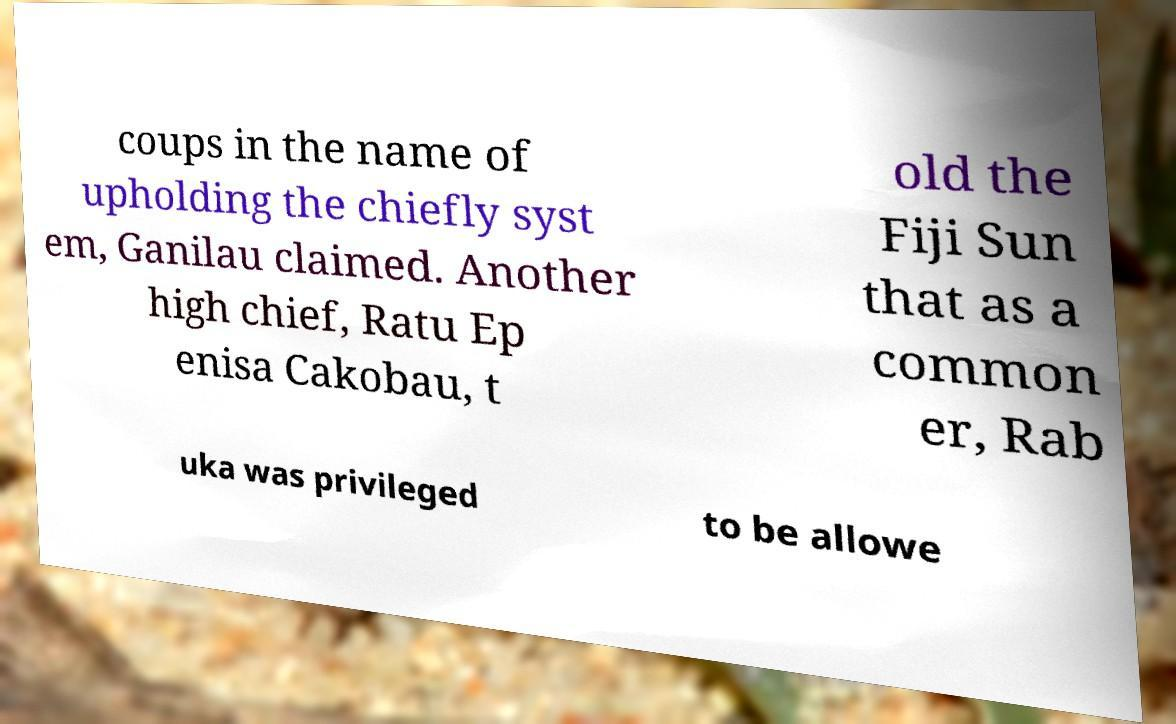Can you accurately transcribe the text from the provided image for me? coups in the name of upholding the chiefly syst em, Ganilau claimed. Another high chief, Ratu Ep enisa Cakobau, t old the Fiji Sun that as a common er, Rab uka was privileged to be allowe 